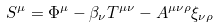<formula> <loc_0><loc_0><loc_500><loc_500>S ^ { \mu } = \Phi ^ { \mu } - \beta _ { \nu } T ^ { \mu \nu } - A ^ { \mu \nu \rho } \xi _ { \nu \rho }</formula> 